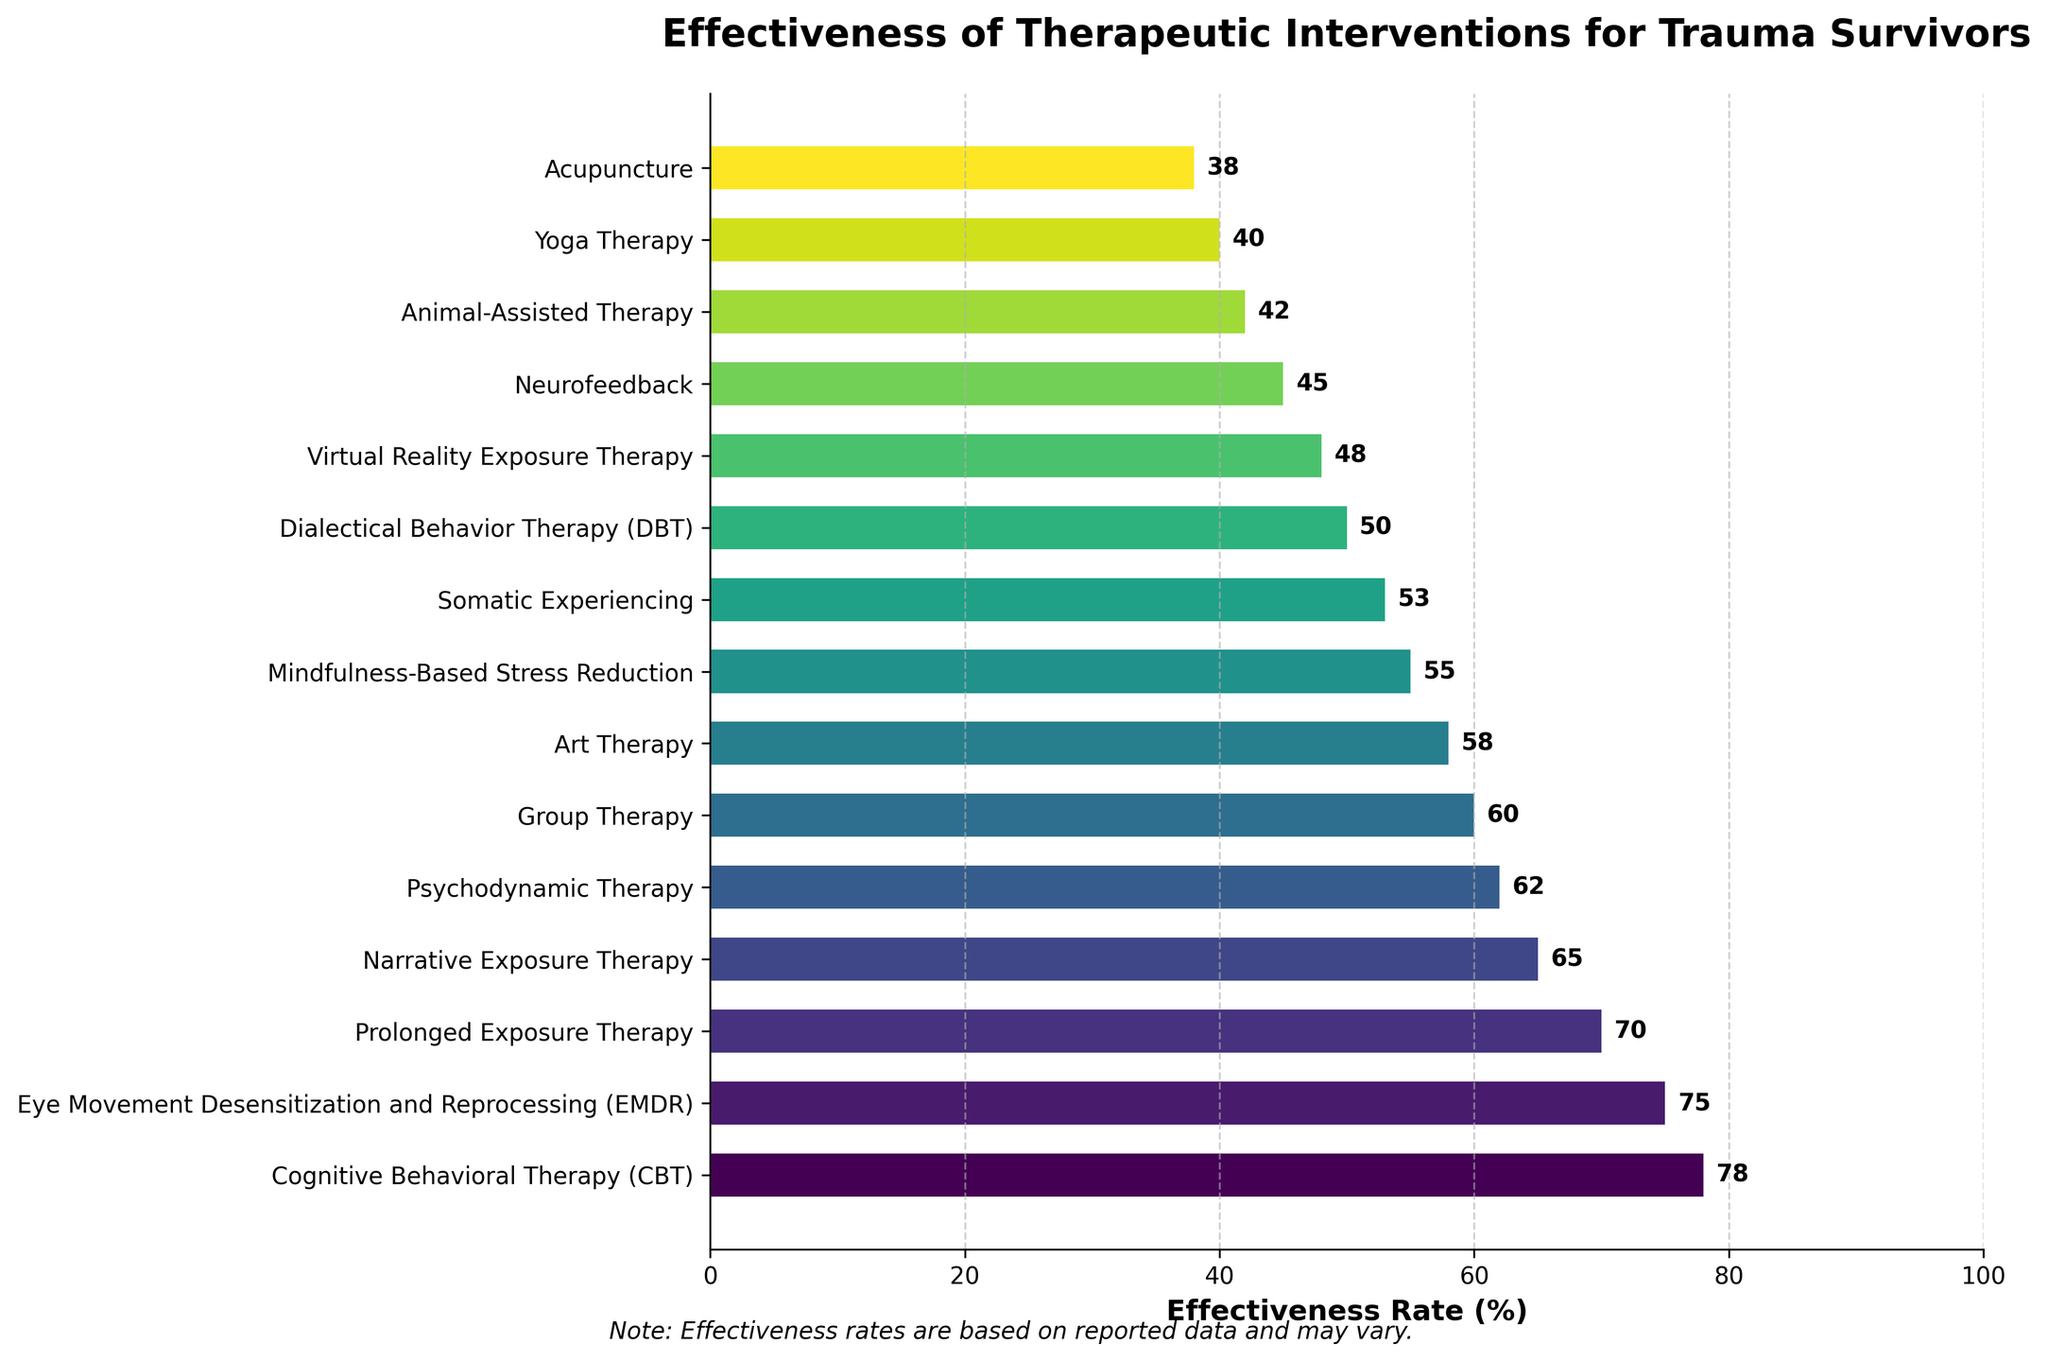Which therapeutic intervention has the highest reported effectiveness rate? The bar chart visually presents the effectiveness rates for various interventions. The longest bar corresponds to Cognitive Behavioral Therapy (CBT) with a rate of 78%.
Answer: Cognitive Behavioral Therapy (CBT) Which therapy has the lowest reported effectiveness rate? The shortest bar represents Acupuncture with an effectiveness rate of 38%.
Answer: Acupuncture How much higher is the effectiveness rate of EMDR compared to Art Therapy? The effectiveness rate of EMDR is 75%, and Art Therapy is 58%. The difference is 75% - 58% = 17%.
Answer: 17% Which therapies have effectiveness rates below the median effectiveness rate, and what are those rates? The median effectiveness rate can be found by ordering the rates: (78, 75, 70, 65, 62, 60, 58, 55, 53, 50, 48, 45, 42, 40, 38). The median rate for 15 data points lies at the 8th position in this ordered list, which is 55%. Therapies below 55% are Somatic Experiencing (53%), DBT (50%), Virtual Reality Exposure Therapy (48%), Neurofeedback (45%), Animal-Assisted Therapy (42%), Yoga Therapy (40%), and Acupuncture (38%).
Answer: Somatic Experiencing (53%), Dialectical Behavior Therapy (DBT) (50%), Virtual Reality Exposure Therapy (48%), Neurofeedback (45%), Animal-Assisted Therapy (42%), Yoga Therapy (40%), Acupuncture (38%) Which therapy has nearly the same effectiveness rate as Group Therapy? Group Therapy has an effectiveness rate of 60%. Looking at the bars, Psychodynamic Therapy has a rate of 62%, which is closest to 60%.
Answer: Psychodynamic Therapy Is the effectiveness rate of Virtual Reality Exposure Therapy higher or lower than Dialectical Behavior Therapy (DBT), and by how much? The bar for Virtual Reality Exposure Therapy shows 48%, while DBT shows 50%. Virtual Reality Exposure Therapy is 50% - 48% = 2% lower.
Answer: Lower by 2% What is the combined effectiveness rate of the three most effective therapies? The most effective therapies by rate are CBT (78%), EMDR (75%), and Prolonged Exposure Therapy (70%). Adding these: 78% + 75% + 70% = 223%.
Answer: 223% Which therapy has an effectiveness rate closest to the average effectiveness rate of all the interventions? To find the average, sum all effectiveness rates and divide by the number of interventions: 
(78 + 75 + 70 + 65 + 62 + 60 + 58 + 55 + 53 + 50 + 48 + 45 + 42 + 40 + 38) / 15 = 906 / 15 = 60.4%. 
Group Therapy has an effectiveness rate of 60%, which is closest to 60.4%.
Answer: Group Therapy Which therapeutic interventions have effectiveness rates within 10% of each other? To identify therapies within a 10% range, compare effectiveness rates and check differences. For instance, 
Narrative Exposure Therapy (65%) and Psychodynamic Therapy (62%): 3% difference,
Group Therapy (60%) and Art Therapy (58%): 2% difference,
EMDR (75%) and Prolonged Exposure Therapy (70%): 5% difference.
Several pairs meet this criterion.
Answer: Multiple pairs, e.g., Narrative Exposure (65%) and Psychodynamic Therapy (62%), Group Therapy (60%) and Art Therapy (58%), EMDR (75%) and Prolonged Exposure Therapy (70%) 